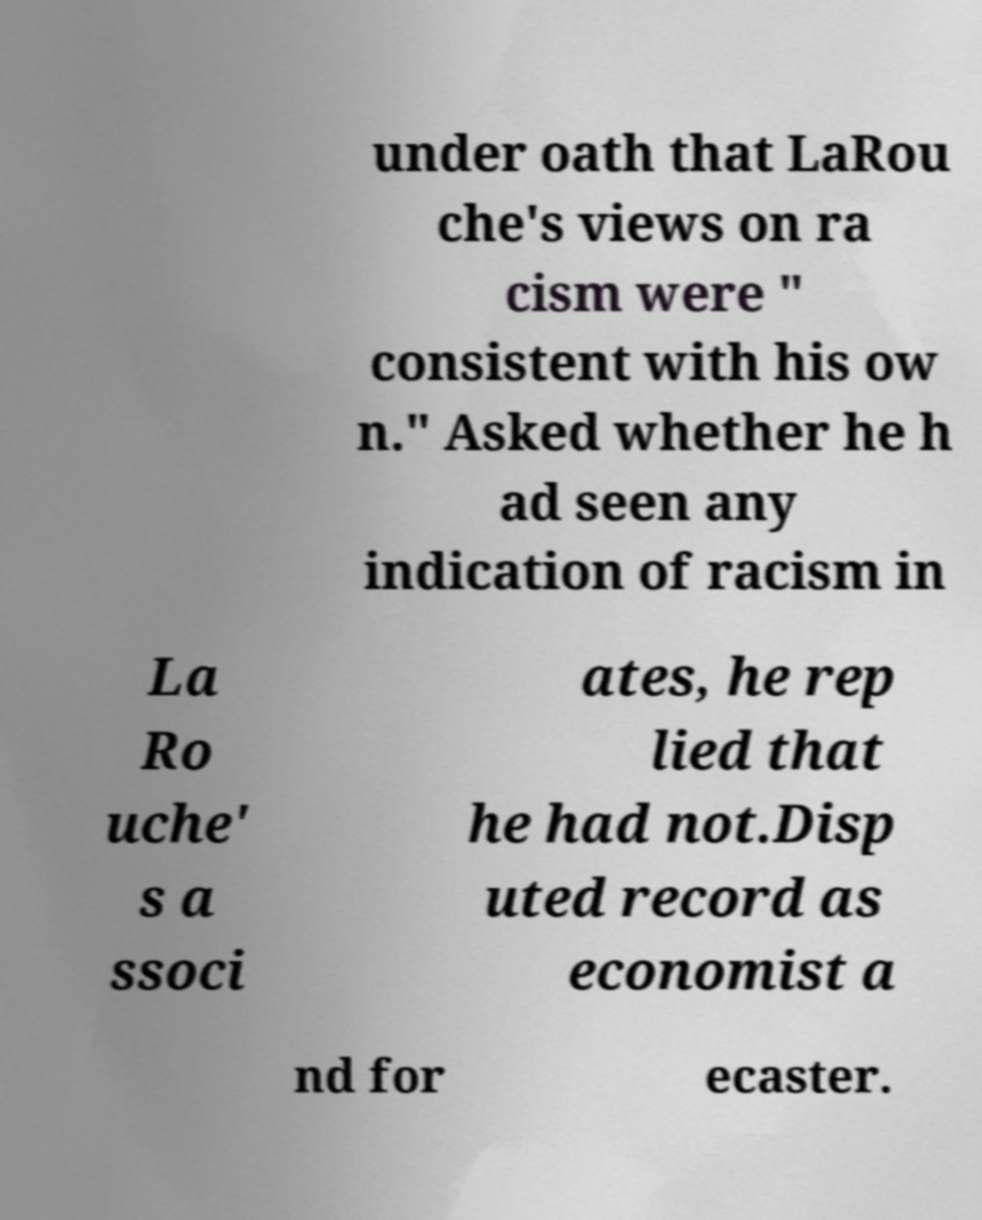What messages or text are displayed in this image? I need them in a readable, typed format. under oath that LaRou che's views on ra cism were " consistent with his ow n." Asked whether he h ad seen any indication of racism in La Ro uche' s a ssoci ates, he rep lied that he had not.Disp uted record as economist a nd for ecaster. 